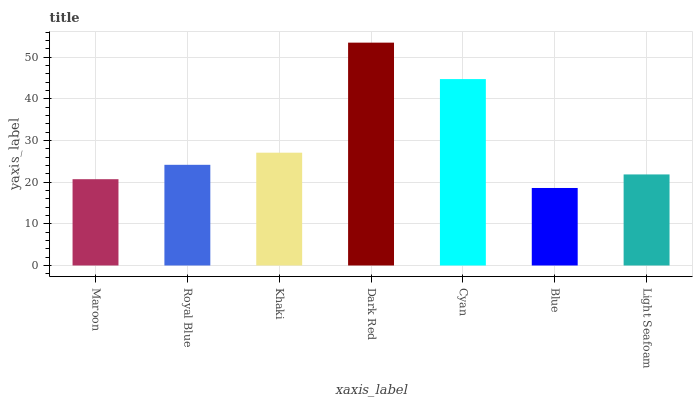Is Blue the minimum?
Answer yes or no. Yes. Is Dark Red the maximum?
Answer yes or no. Yes. Is Royal Blue the minimum?
Answer yes or no. No. Is Royal Blue the maximum?
Answer yes or no. No. Is Royal Blue greater than Maroon?
Answer yes or no. Yes. Is Maroon less than Royal Blue?
Answer yes or no. Yes. Is Maroon greater than Royal Blue?
Answer yes or no. No. Is Royal Blue less than Maroon?
Answer yes or no. No. Is Royal Blue the high median?
Answer yes or no. Yes. Is Royal Blue the low median?
Answer yes or no. Yes. Is Light Seafoam the high median?
Answer yes or no. No. Is Khaki the low median?
Answer yes or no. No. 